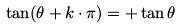<formula> <loc_0><loc_0><loc_500><loc_500>\tan ( \theta + k \cdot \pi ) = + \tan \theta</formula> 